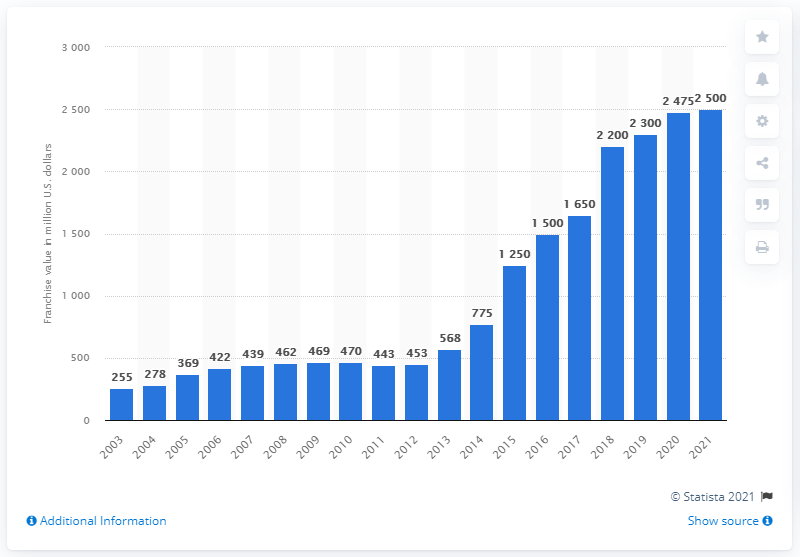Give some essential details in this illustration. The estimated value of the Houston Rockets franchise in 2021 was approximately 2,500. 